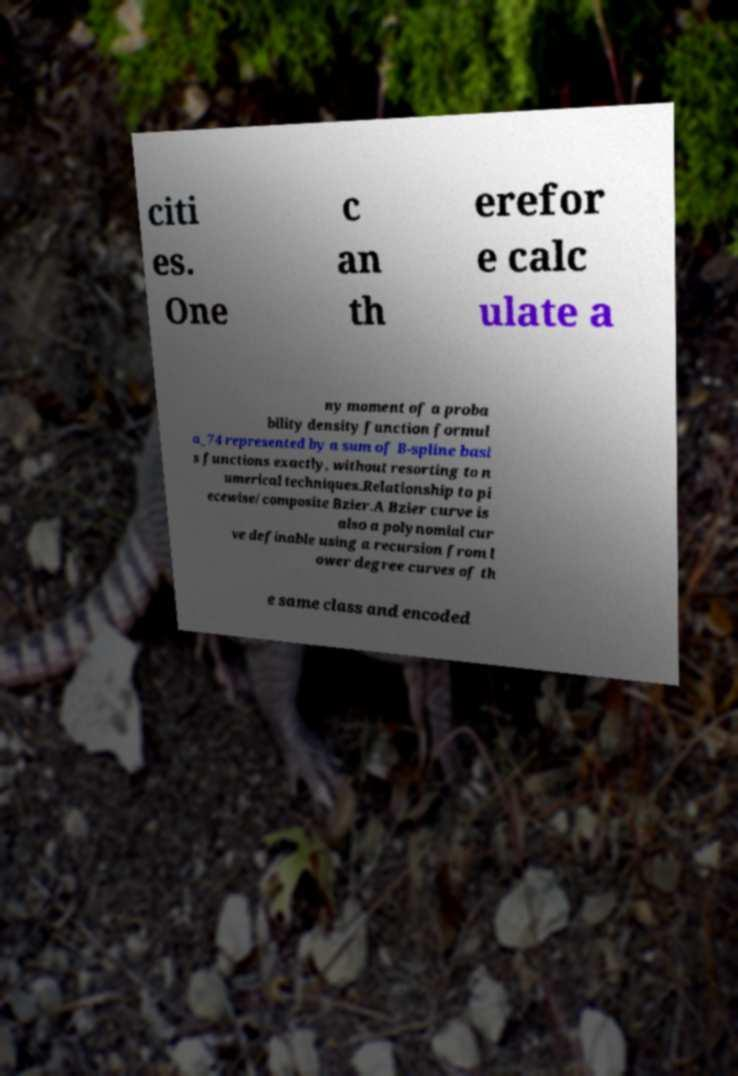For documentation purposes, I need the text within this image transcribed. Could you provide that? citi es. One c an th erefor e calc ulate a ny moment of a proba bility density function formul a_74 represented by a sum of B-spline basi s functions exactly, without resorting to n umerical techniques.Relationship to pi ecewise/composite Bzier.A Bzier curve is also a polynomial cur ve definable using a recursion from l ower degree curves of th e same class and encoded 